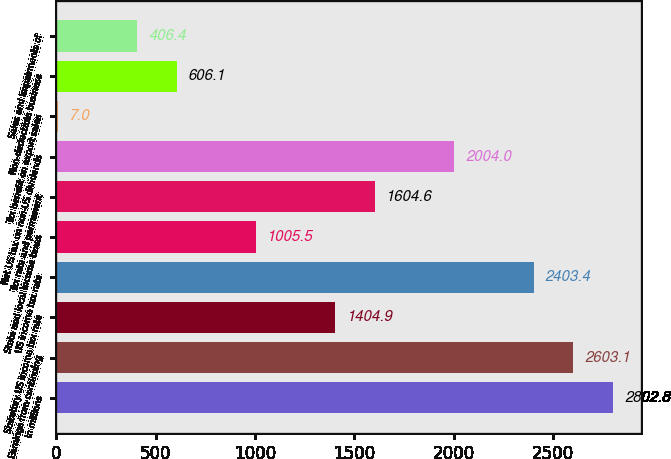<chart> <loc_0><loc_0><loc_500><loc_500><bar_chart><fcel>In millions<fcel>Earnings from continuing<fcel>Statutory US income tax rate<fcel>US income tax rate<fcel>State and local income taxes<fcel>Tax rate and permanent<fcel>Net US tax on non-US dividends<fcel>Tax benefit on export sales<fcel>Non-deductible business<fcel>Sales and impairments of<nl><fcel>2802.8<fcel>2603.1<fcel>1404.9<fcel>2403.4<fcel>1005.5<fcel>1604.6<fcel>2004<fcel>7<fcel>606.1<fcel>406.4<nl></chart> 